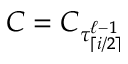<formula> <loc_0><loc_0><loc_500><loc_500>C = C _ { \tau _ { \lceil i / 2 \rceil } ^ { \ell - 1 } }</formula> 